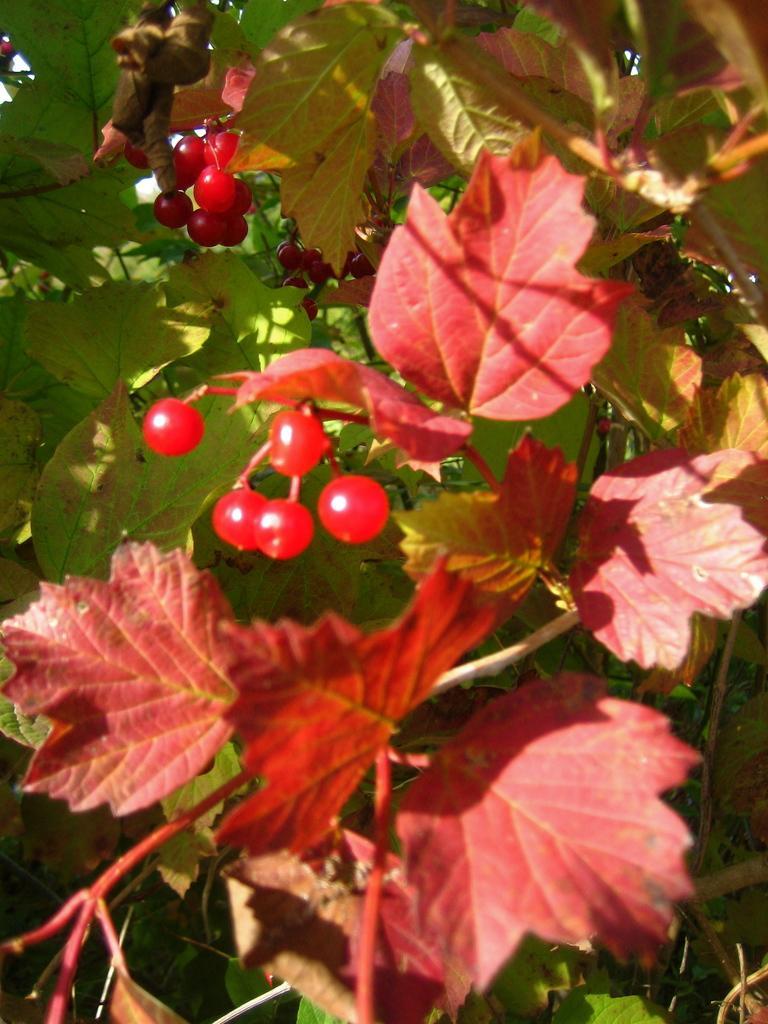Can you describe this image briefly? In this image there are few plants having leaves and fruits to it. 